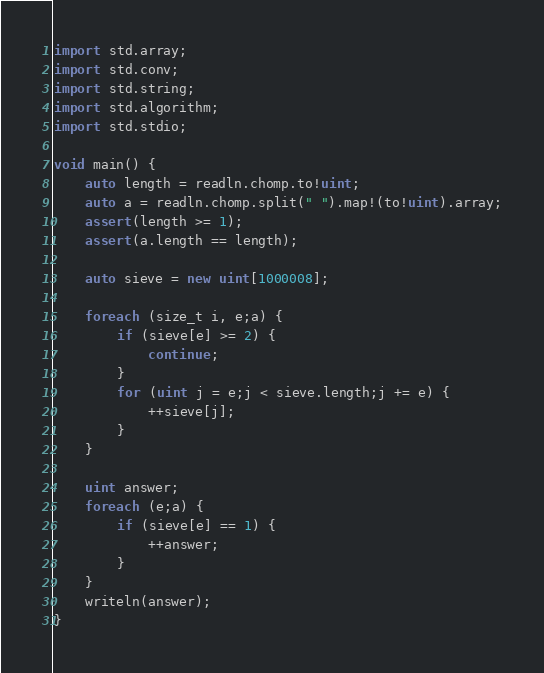Convert code to text. <code><loc_0><loc_0><loc_500><loc_500><_D_>import std.array;
import std.conv;
import std.string;
import std.algorithm;
import std.stdio;

void main() {
	auto length = readln.chomp.to!uint;
	auto a = readln.chomp.split(" ").map!(to!uint).array;
	assert(length >= 1);
	assert(a.length == length);

	auto sieve = new uint[1000008];

	foreach (size_t i, e;a) {
		if (sieve[e] >= 2) {
			continue;
		}
		for (uint j = e;j < sieve.length;j += e) {
			++sieve[j];
		}
	}

	uint answer;
	foreach (e;a) {
		if (sieve[e] == 1) {
			++answer;
		}
	}
	writeln(answer);
}
</code> 